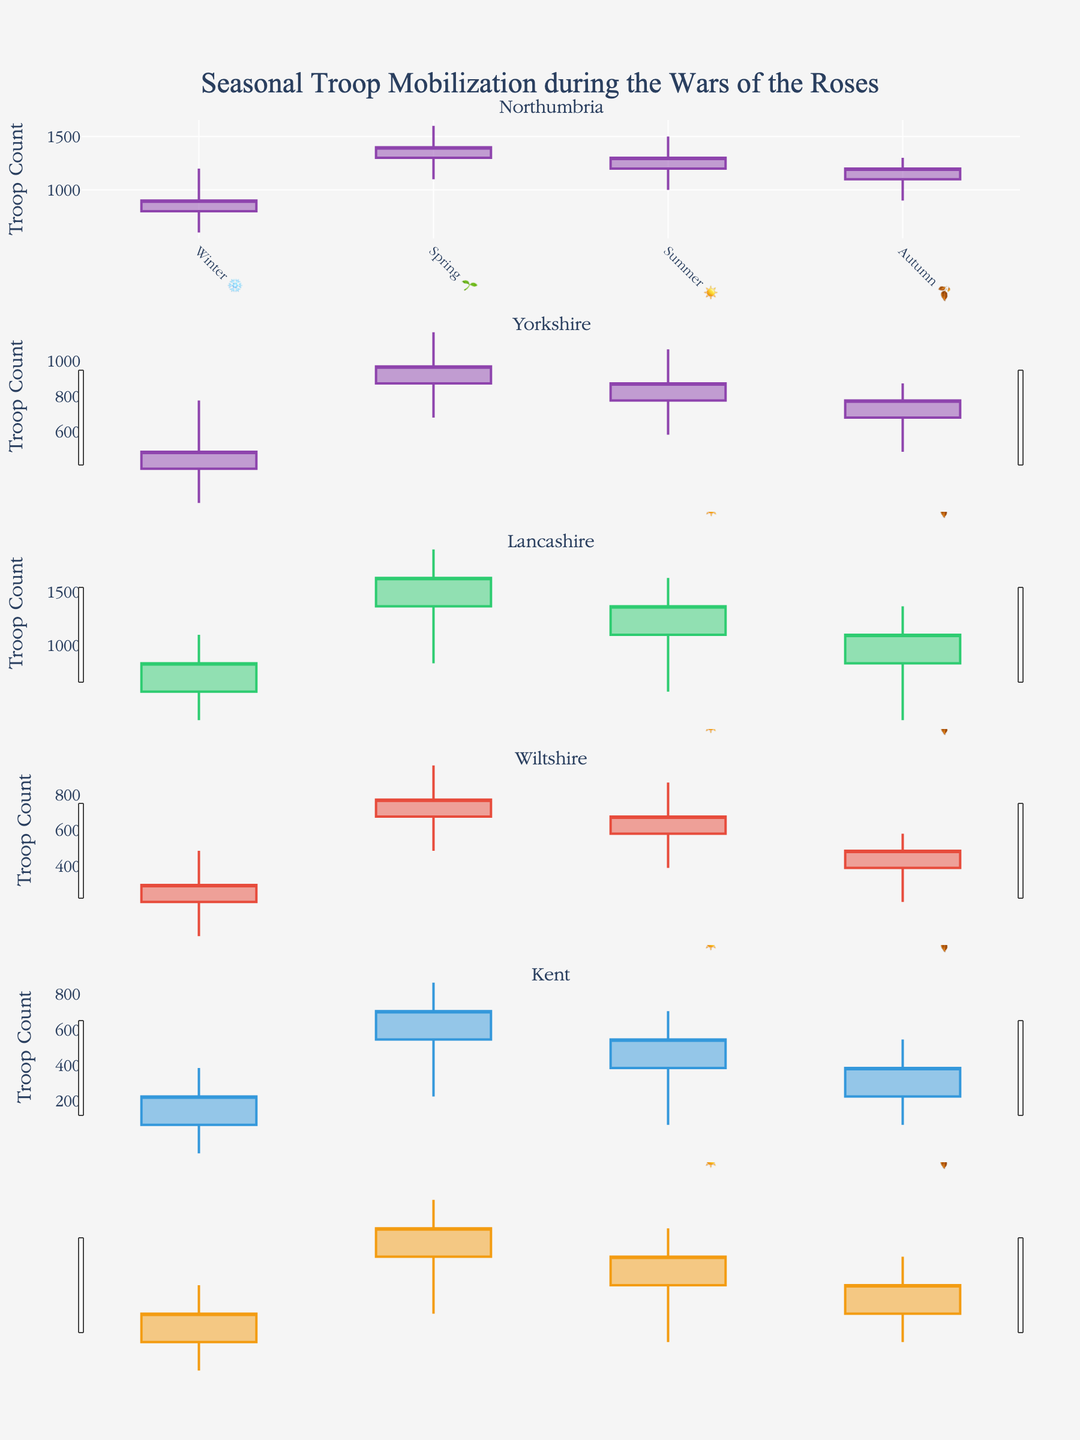What is the title of the figure? The title of the figure is displayed at the top.
Answer: Seasonal Troop Mobilization during the Wars of the Roses Which region has the highest troop count in Winter? Look at the candlestick for Winter in each subplot and identify the highest high value.
Answer: Northumbria What is the range of troop counts in Lancashire during Spring? For the Spring candlestick in Lancashire, find the difference between the High and Low values.
Answer: 500 Which season shows the lowest troop mobilization in Kent? Look at the Lowest value among the four candlesticks for Kent and identify the corresponding season.
Answer: Winter How do troop mobilizations in Northumbria and Yorkshire compare during Summer? Compare the High, Low, Open, and Close values of the Summer candlesticks for both regions. Northumbria generally has higher values than Yorkshire in each case.
Answer: Higher in Northumbria What is the total variation (High - Low) in troop mobilization for all seasons in Wiltshire? Sum the difference (High - Low) for all four seasons' candlesticks in Wiltshire. (Winter: 300, Spring: 400, Summer: 400, Autumn: 300)
Answer: 1400 Which region shows the most significant drop in troop mobilization from Spring to Summer? Identify the region with the largest difference in the Close values between Spring and Summer. Check the figures for each region and find the maximum change between these seasons.
Answer: Northumbria During which season does Northumbria have the highest overall troop count increase? An increase in troop count is marked by an increasing line (Open to Close). Identify the season with the greatest vertical difference between Open and Close.
Answer: Spring What seasonal pattern can be observed in troop mobilization in Yorkshire? Examine the candlesticks for trends in each season: Winter has lower values, increasing in Spring, and then decreasing again through Summer and Autumn.
Answer: Increase in Spring, decrease afterwards Is there any region where the Autumn troop count is consistently higher than the Summer troop count? Compare the Close values for Summer and Autumn in each region. None of the Close values in Autumn are higher than in Summer for any region.
Answer: No 